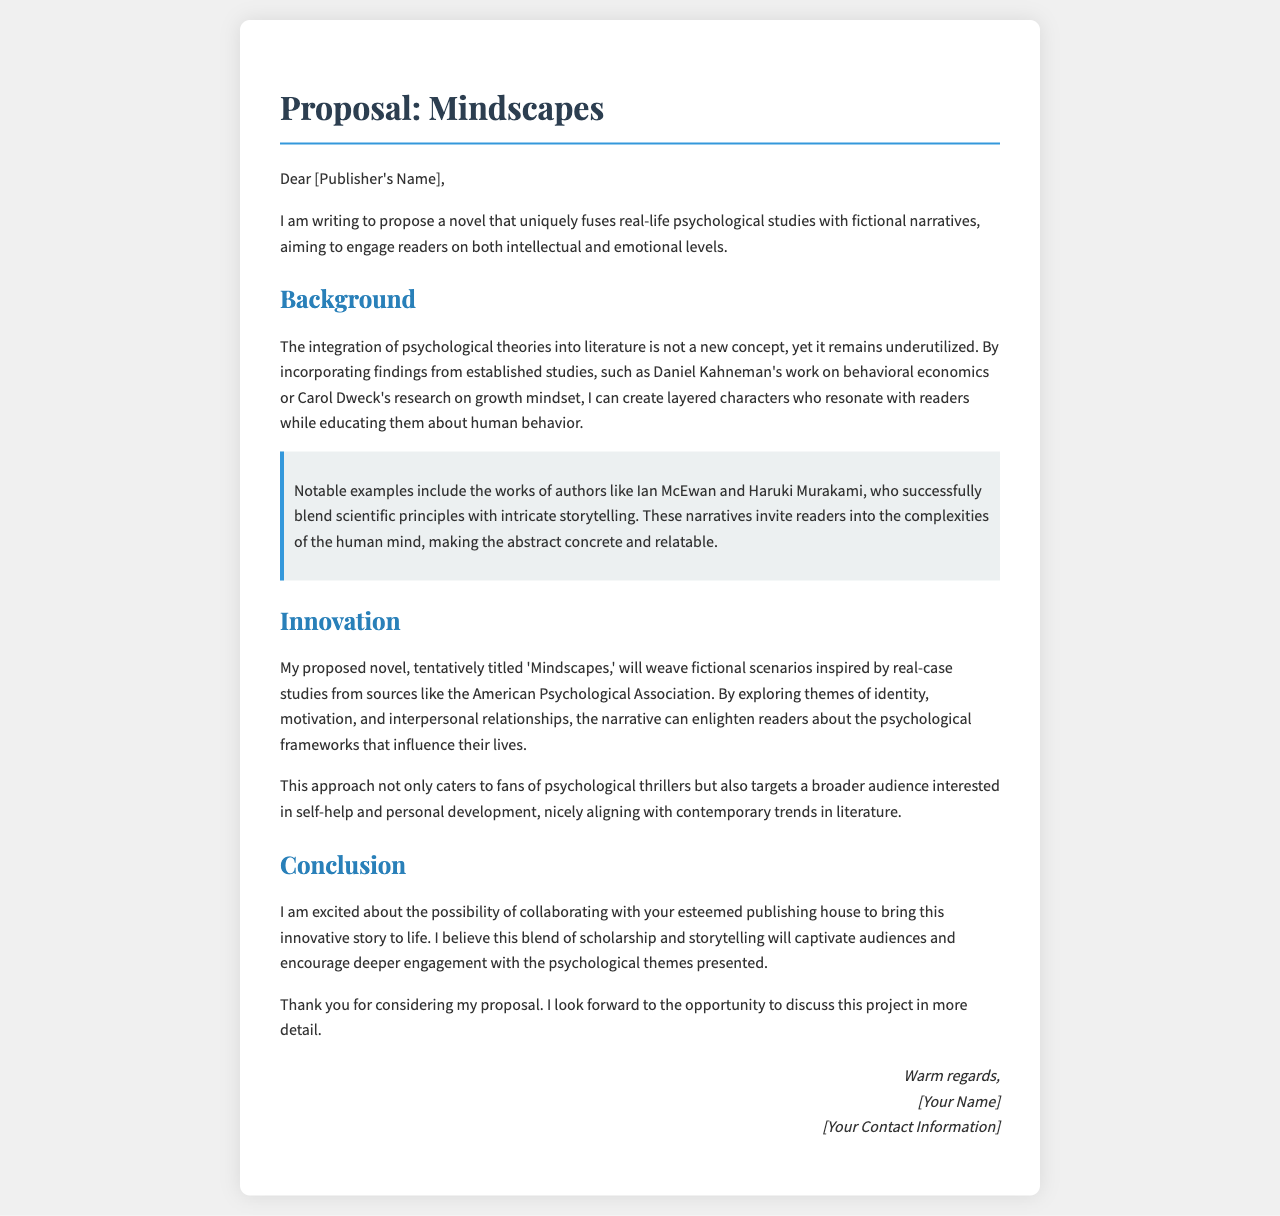what is the title of the proposed novel? The title of the proposed novel is found in the document's heading, specifically mentioned as 'Mindscapes.'
Answer: Mindscapes who is the author of the proposal? The author of the proposal is indicated at the end of the document, just before the signature.
Answer: [Your Name] what field does the proposed novel aim to fuse with fiction? The proposal discusses incorporating psychological studies into the narrative, which is specified in the introduction.
Answer: psychological studies which authors are cited as notable examples in the proposal? The proposal mentions successful authors who blend science with storytelling, specifically naming them in the background section.
Answer: Ian McEwan and Haruki Murakami what significant themes will the narrative explore? The proposal outlines key themes that the fictional narrative will address, which are mentioned in the innovation section.
Answer: identity, motivation, and interpersonal relationships what type of audience is the proposed novel targeting? The proposal describes the intended audience, referring to both specific genres and broader interests, outlined in the innovation section.
Answer: psychological thrillers and self-help which organization’s case studies will inspire the fictional scenarios? The source of case studies that will inspire the narrative is explicitly mentioned in the innovation section.
Answer: American Psychological Association what does the author hope to achieve by merging scholarship and storytelling? The proposal expresses the author's intended impact through the fusion of two elements, which is stated in the conclusion.
Answer: captivate audiences 